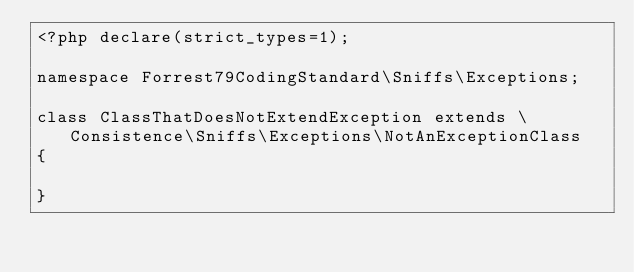<code> <loc_0><loc_0><loc_500><loc_500><_PHP_><?php declare(strict_types=1);

namespace Forrest79CodingStandard\Sniffs\Exceptions;

class ClassThatDoesNotExtendException extends \Consistence\Sniffs\Exceptions\NotAnExceptionClass
{

}
</code> 